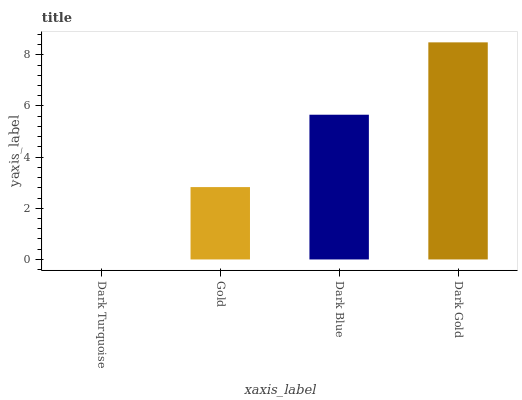Is Gold the minimum?
Answer yes or no. No. Is Gold the maximum?
Answer yes or no. No. Is Gold greater than Dark Turquoise?
Answer yes or no. Yes. Is Dark Turquoise less than Gold?
Answer yes or no. Yes. Is Dark Turquoise greater than Gold?
Answer yes or no. No. Is Gold less than Dark Turquoise?
Answer yes or no. No. Is Dark Blue the high median?
Answer yes or no. Yes. Is Gold the low median?
Answer yes or no. Yes. Is Dark Turquoise the high median?
Answer yes or no. No. Is Dark Turquoise the low median?
Answer yes or no. No. 